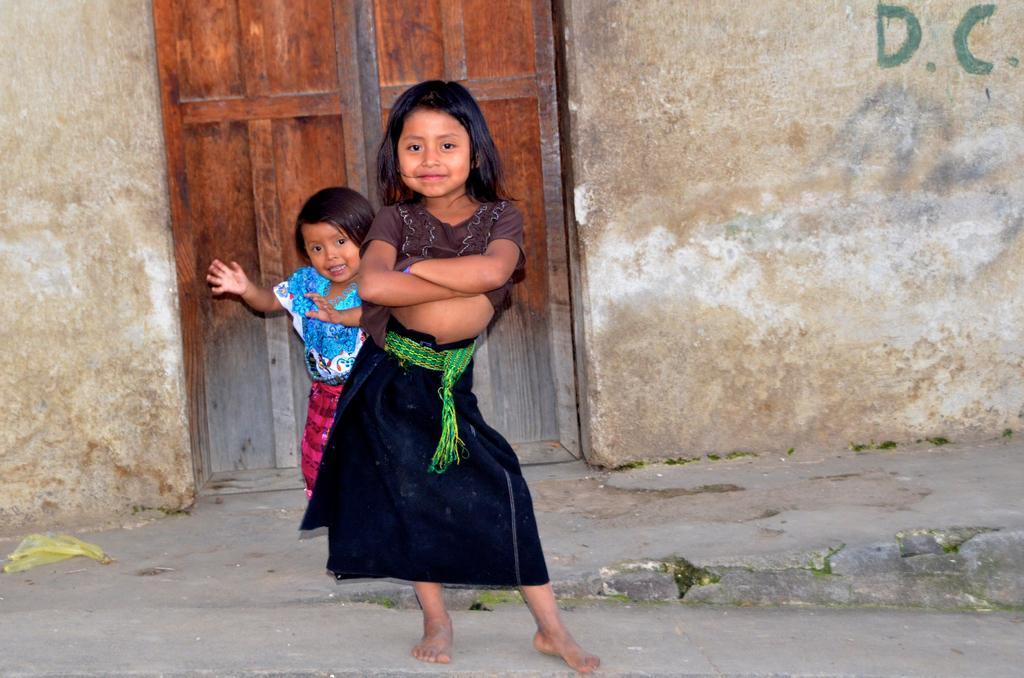Can you describe this image briefly? In the picture we can see two small girls are standing on the path with different poses and behind them, we can see the wall with a door to it. 